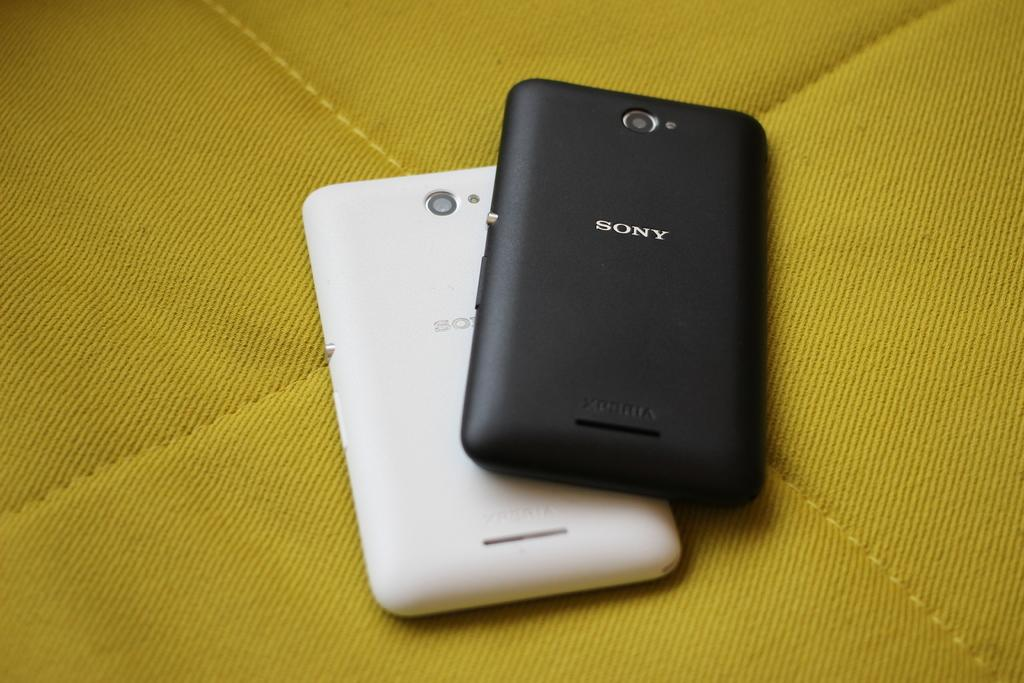Provide a one-sentence caption for the provided image. A black Sony phone is laid on top of a white one. 